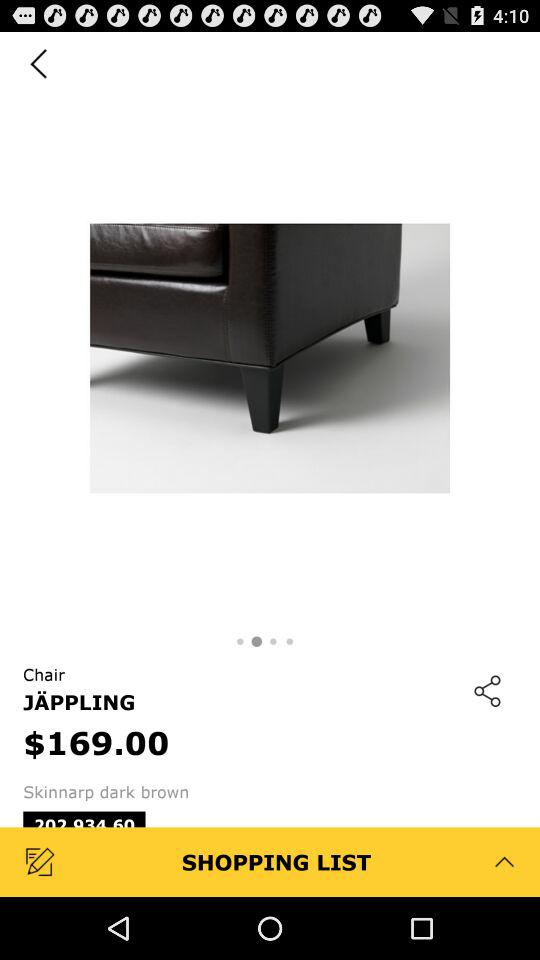What is the price of the product?
Answer the question using a single word or phrase. $169.00 